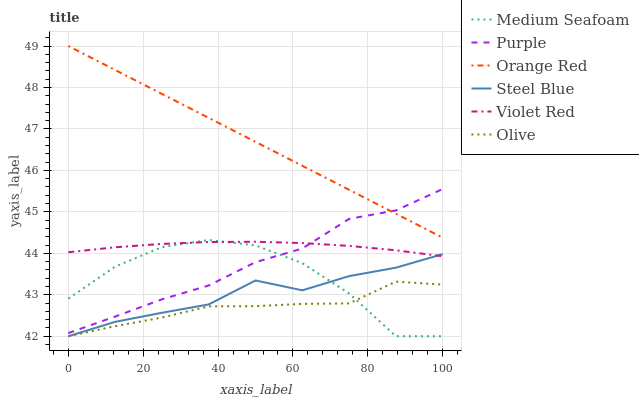Does Olive have the minimum area under the curve?
Answer yes or no. Yes. Does Orange Red have the maximum area under the curve?
Answer yes or no. Yes. Does Purple have the minimum area under the curve?
Answer yes or no. No. Does Purple have the maximum area under the curve?
Answer yes or no. No. Is Orange Red the smoothest?
Answer yes or no. Yes. Is Medium Seafoam the roughest?
Answer yes or no. Yes. Is Purple the smoothest?
Answer yes or no. No. Is Purple the roughest?
Answer yes or no. No. Does Steel Blue have the lowest value?
Answer yes or no. Yes. Does Purple have the lowest value?
Answer yes or no. No. Does Orange Red have the highest value?
Answer yes or no. Yes. Does Purple have the highest value?
Answer yes or no. No. Is Violet Red less than Orange Red?
Answer yes or no. Yes. Is Orange Red greater than Medium Seafoam?
Answer yes or no. Yes. Does Orange Red intersect Purple?
Answer yes or no. Yes. Is Orange Red less than Purple?
Answer yes or no. No. Is Orange Red greater than Purple?
Answer yes or no. No. Does Violet Red intersect Orange Red?
Answer yes or no. No. 